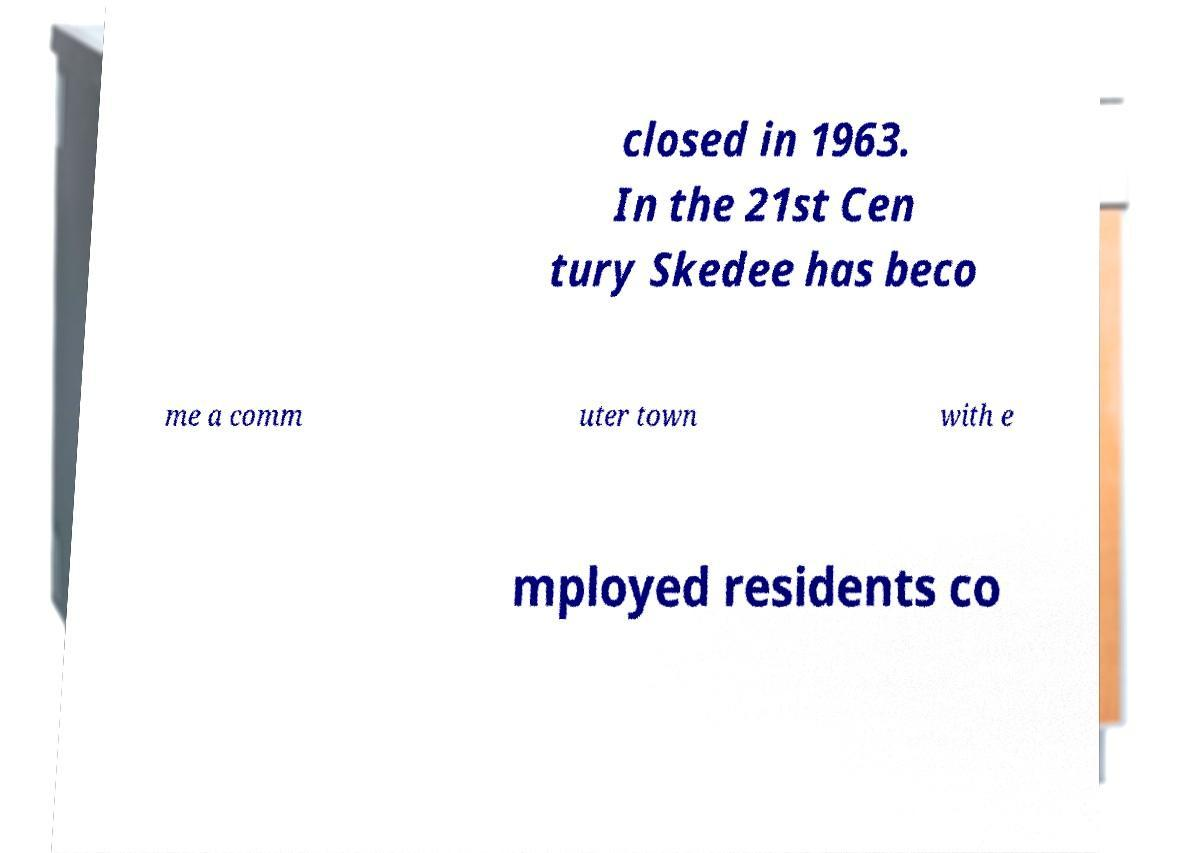Please identify and transcribe the text found in this image. closed in 1963. In the 21st Cen tury Skedee has beco me a comm uter town with e mployed residents co 